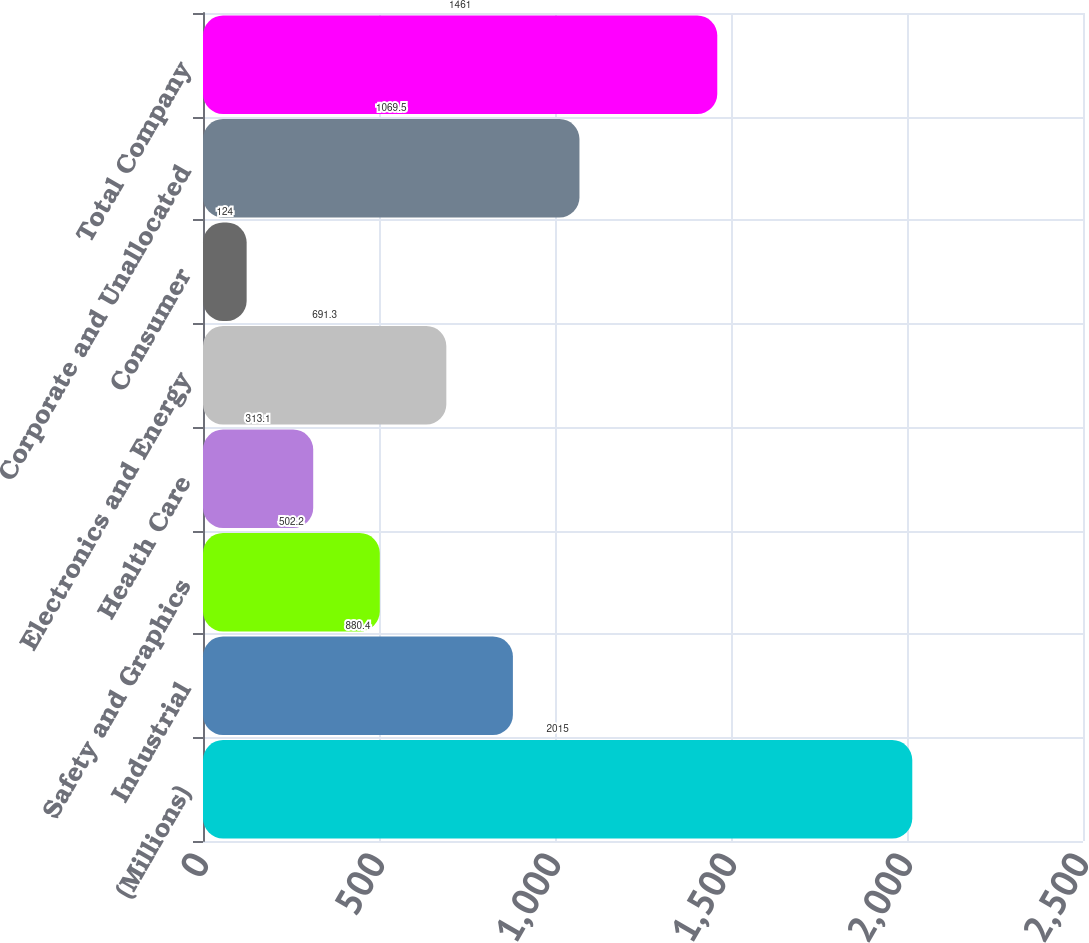Convert chart. <chart><loc_0><loc_0><loc_500><loc_500><bar_chart><fcel>(Millions)<fcel>Industrial<fcel>Safety and Graphics<fcel>Health Care<fcel>Electronics and Energy<fcel>Consumer<fcel>Corporate and Unallocated<fcel>Total Company<nl><fcel>2015<fcel>880.4<fcel>502.2<fcel>313.1<fcel>691.3<fcel>124<fcel>1069.5<fcel>1461<nl></chart> 